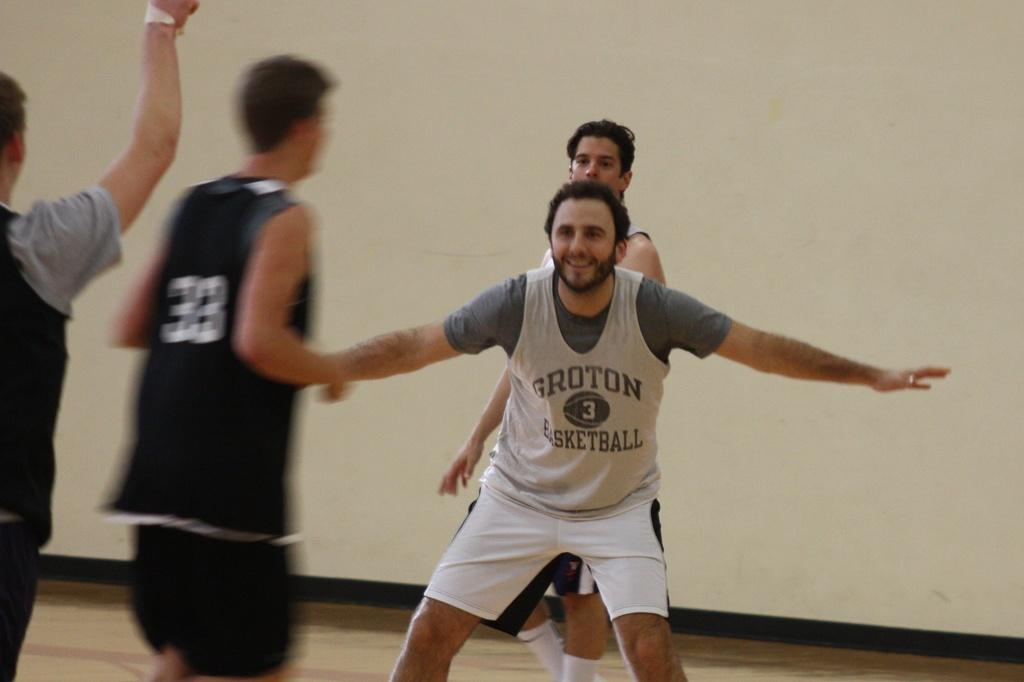<image>
Describe the image concisely. Groton basketball players playing on the basketball court 